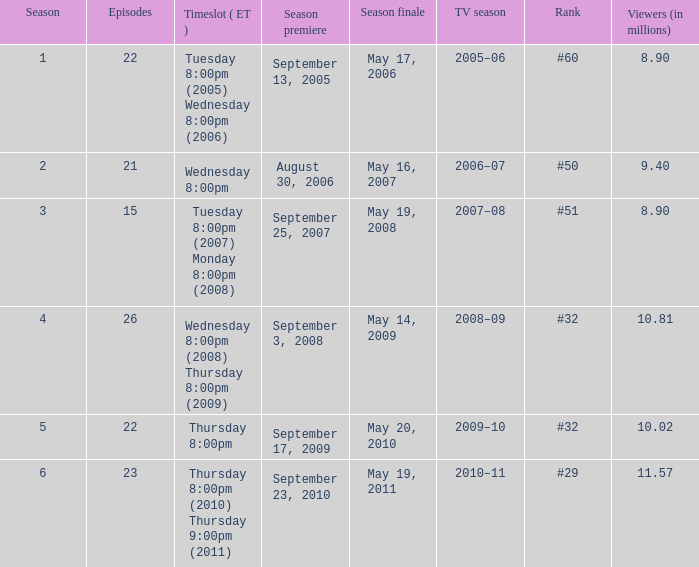Write the full table. {'header': ['Season', 'Episodes', 'Timeslot ( ET )', 'Season premiere', 'Season finale', 'TV season', 'Rank', 'Viewers (in millions)'], 'rows': [['1', '22', 'Tuesday 8:00pm (2005) Wednesday 8:00pm (2006)', 'September 13, 2005', 'May 17, 2006', '2005–06', '#60', '8.90'], ['2', '21', 'Wednesday 8:00pm', 'August 30, 2006', 'May 16, 2007', '2006–07', '#50', '9.40'], ['3', '15', 'Tuesday 8:00pm (2007) Monday 8:00pm (2008)', 'September 25, 2007', 'May 19, 2008', '2007–08', '#51', '8.90'], ['4', '26', 'Wednesday 8:00pm (2008) Thursday 8:00pm (2009)', 'September 3, 2008', 'May 14, 2009', '2008–09', '#32', '10.81'], ['5', '22', 'Thursday 8:00pm', 'September 17, 2009', 'May 20, 2010', '2009–10', '#32', '10.02'], ['6', '23', 'Thursday 8:00pm (2010) Thursday 9:00pm (2011)', 'September 23, 2010', 'May 19, 2011', '2010–11', '#29', '11.57']]} 02 million viewers? May 20, 2010. 